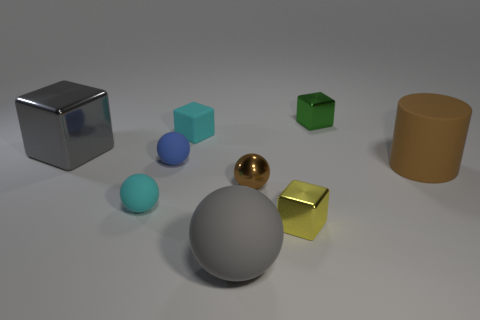Subtract all cubes. How many objects are left? 5 Subtract all tiny green metallic cubes. Subtract all brown things. How many objects are left? 6 Add 9 brown shiny things. How many brown shiny things are left? 10 Add 3 tiny rubber cubes. How many tiny rubber cubes exist? 4 Subtract 0 purple balls. How many objects are left? 9 